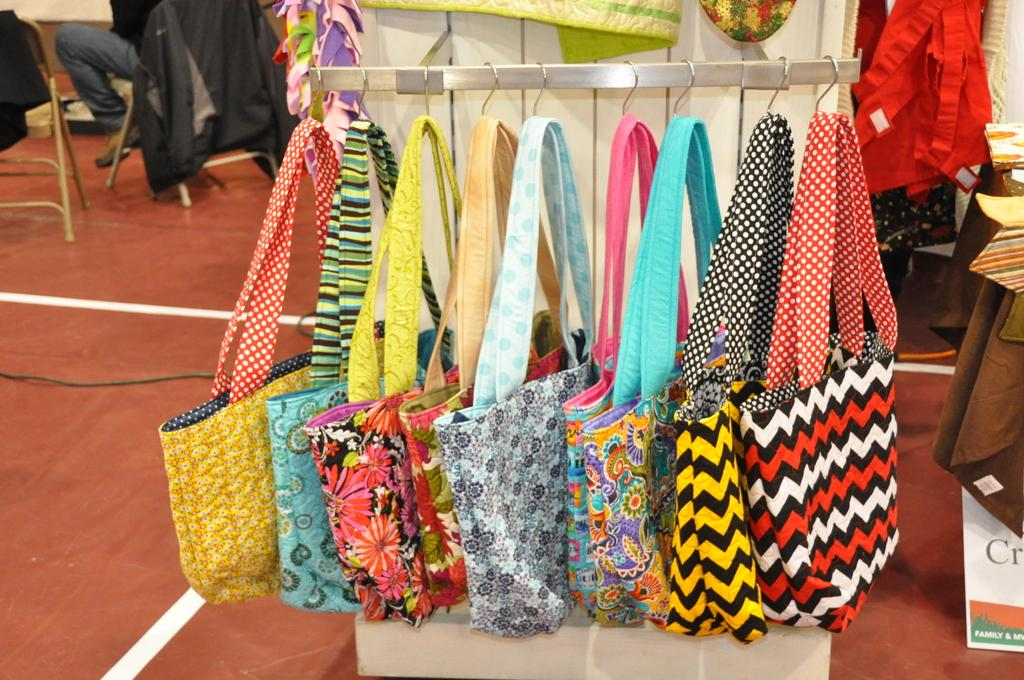What is hanging in the image? There are bags hanging in the image. What can be seen in the background of the image? There are clothes visible in the background. What is the person in the image doing? The person is sitting on a chair. What is the person wearing? The person is wearing a jacket. How many chairs are visible in the image? There are two chairs visible in the image. How many women are holding bananas in the image? There are no women or bananas present in the image. What language is the person speaking in the image? The image does not provide any information about the person speaking or the language being spoken. 